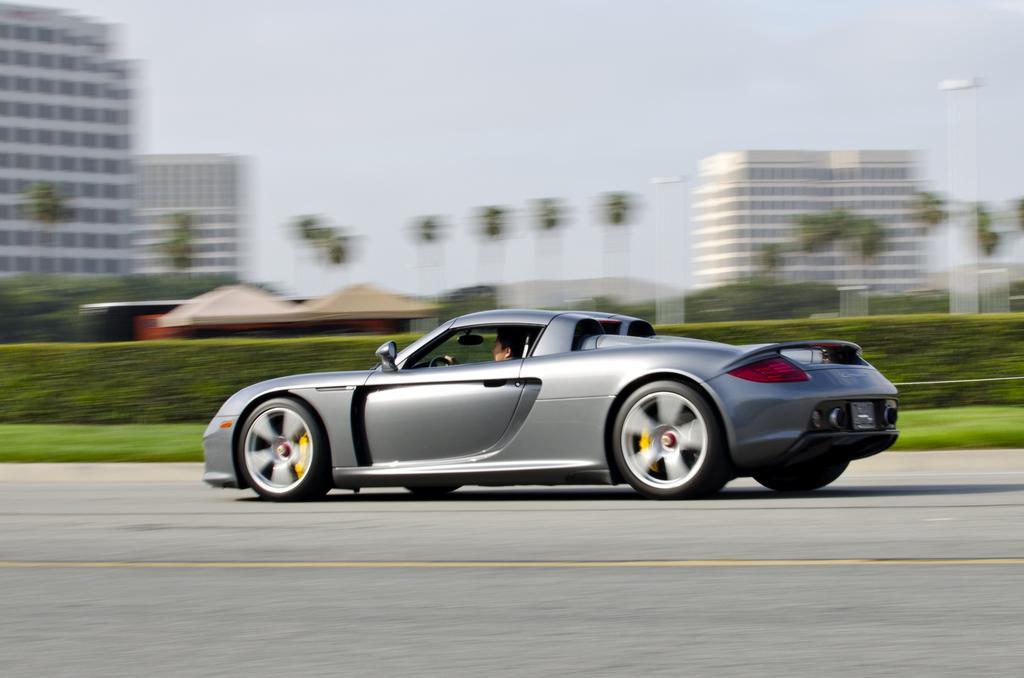Can you describe this image briefly? In this picture we can see a car on the road with a person in it, grass, sheds, trees, buildings and in the background we can see the sky and it is blurry. 